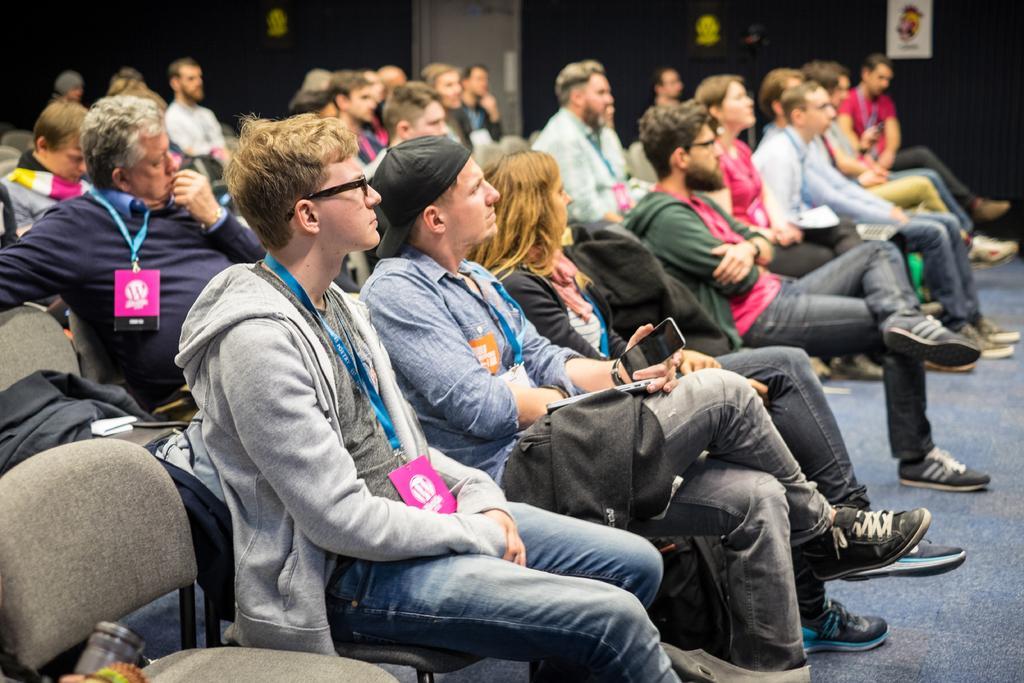Can you describe this image briefly? In the image there are many people sitting on the chairs and all of them are wearing id cards. 